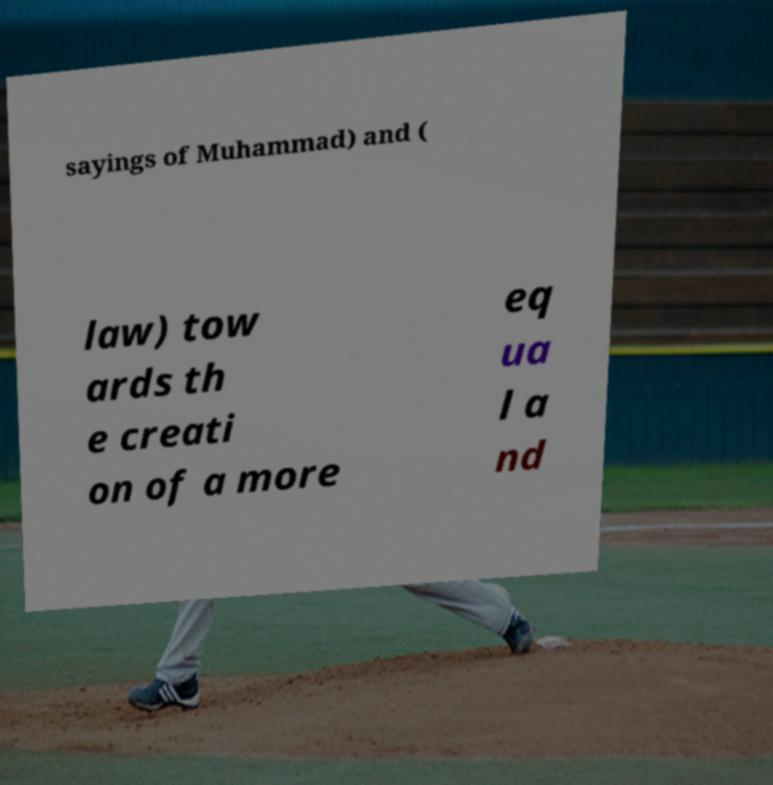Please read and relay the text visible in this image. What does it say? sayings of Muhammad) and ( law) tow ards th e creati on of a more eq ua l a nd 